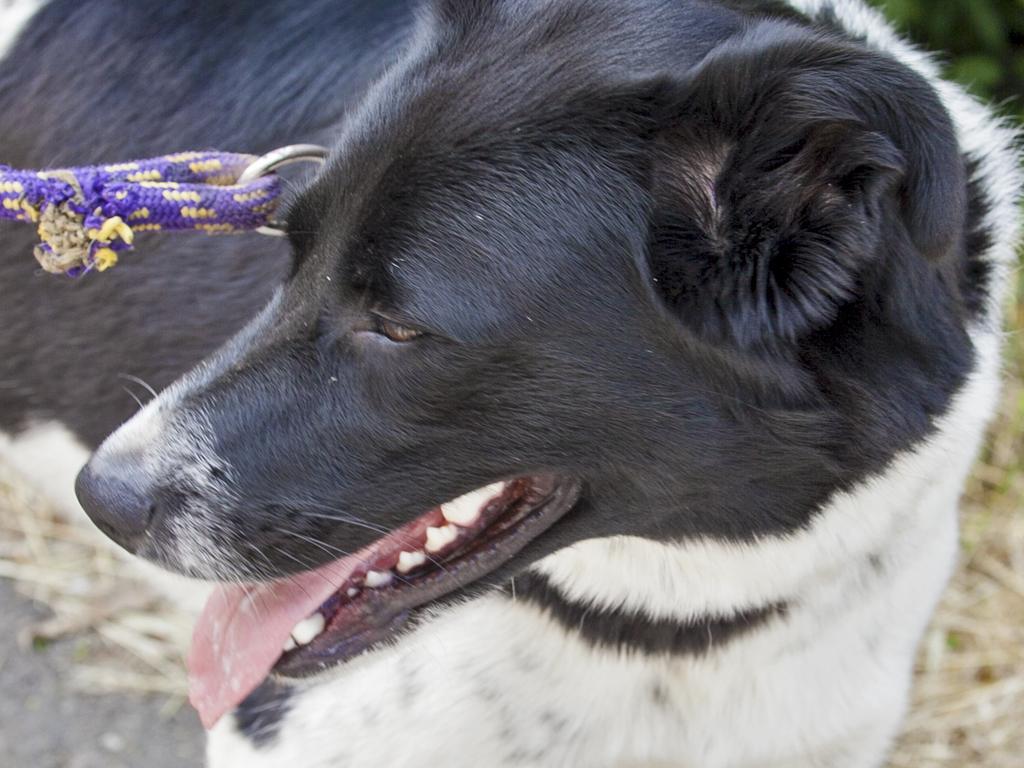Can you describe this image briefly? In this picture there is a dog which is in black and white color and there is a violet color belt tightened to it. 